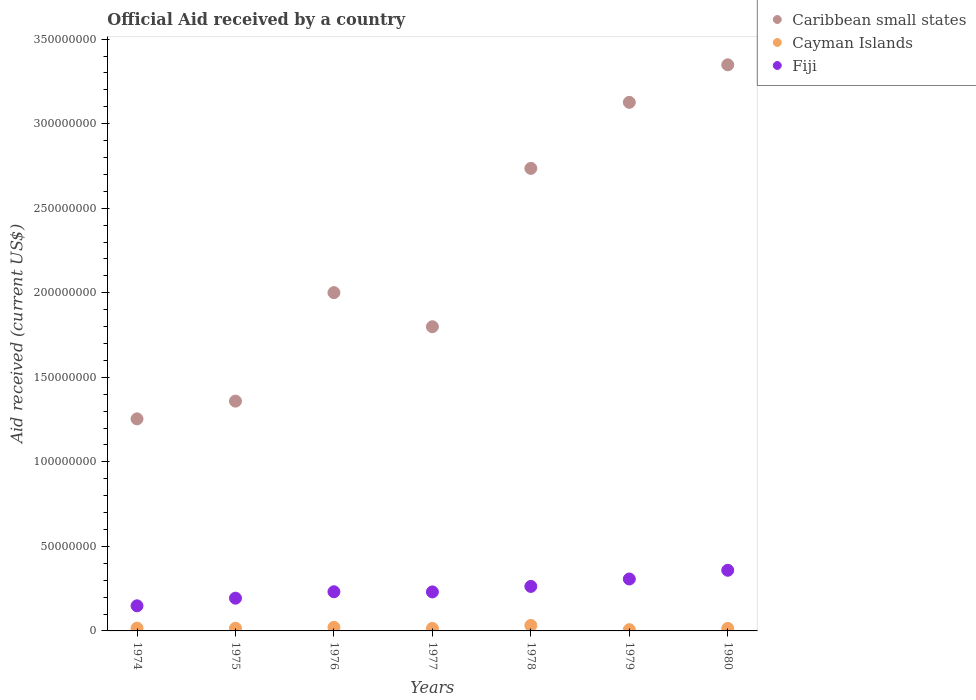How many different coloured dotlines are there?
Provide a succinct answer. 3. Is the number of dotlines equal to the number of legend labels?
Offer a terse response. Yes. What is the net official aid received in Fiji in 1980?
Give a very brief answer. 3.59e+07. Across all years, what is the maximum net official aid received in Caribbean small states?
Your response must be concise. 3.35e+08. Across all years, what is the minimum net official aid received in Caribbean small states?
Provide a succinct answer. 1.25e+08. In which year was the net official aid received in Fiji maximum?
Offer a terse response. 1980. In which year was the net official aid received in Fiji minimum?
Provide a short and direct response. 1974. What is the total net official aid received in Caribbean small states in the graph?
Give a very brief answer. 1.56e+09. What is the difference between the net official aid received in Cayman Islands in 1978 and that in 1979?
Make the answer very short. 2.50e+06. What is the difference between the net official aid received in Fiji in 1979 and the net official aid received in Caribbean small states in 1978?
Make the answer very short. -2.43e+08. What is the average net official aid received in Fiji per year?
Provide a succinct answer. 2.48e+07. In the year 1974, what is the difference between the net official aid received in Cayman Islands and net official aid received in Caribbean small states?
Make the answer very short. -1.24e+08. In how many years, is the net official aid received in Caribbean small states greater than 250000000 US$?
Make the answer very short. 3. What is the ratio of the net official aid received in Caribbean small states in 1974 to that in 1976?
Keep it short and to the point. 0.63. Is the difference between the net official aid received in Cayman Islands in 1977 and 1978 greater than the difference between the net official aid received in Caribbean small states in 1977 and 1978?
Keep it short and to the point. Yes. What is the difference between the highest and the second highest net official aid received in Cayman Islands?
Your answer should be very brief. 1.14e+06. What is the difference between the highest and the lowest net official aid received in Fiji?
Give a very brief answer. 2.10e+07. In how many years, is the net official aid received in Caribbean small states greater than the average net official aid received in Caribbean small states taken over all years?
Provide a short and direct response. 3. Is the net official aid received in Fiji strictly less than the net official aid received in Cayman Islands over the years?
Your answer should be very brief. No. How many dotlines are there?
Make the answer very short. 3. How many years are there in the graph?
Keep it short and to the point. 7. What is the difference between two consecutive major ticks on the Y-axis?
Ensure brevity in your answer.  5.00e+07. Does the graph contain any zero values?
Give a very brief answer. No. Does the graph contain grids?
Offer a very short reply. No. Where does the legend appear in the graph?
Your answer should be very brief. Top right. How are the legend labels stacked?
Your answer should be compact. Vertical. What is the title of the graph?
Give a very brief answer. Official Aid received by a country. Does "Sweden" appear as one of the legend labels in the graph?
Your answer should be very brief. No. What is the label or title of the X-axis?
Your answer should be compact. Years. What is the label or title of the Y-axis?
Offer a terse response. Aid received (current US$). What is the Aid received (current US$) of Caribbean small states in 1974?
Your answer should be very brief. 1.25e+08. What is the Aid received (current US$) of Cayman Islands in 1974?
Ensure brevity in your answer.  1.68e+06. What is the Aid received (current US$) of Fiji in 1974?
Ensure brevity in your answer.  1.48e+07. What is the Aid received (current US$) of Caribbean small states in 1975?
Your response must be concise. 1.36e+08. What is the Aid received (current US$) of Cayman Islands in 1975?
Give a very brief answer. 1.59e+06. What is the Aid received (current US$) of Fiji in 1975?
Provide a succinct answer. 1.94e+07. What is the Aid received (current US$) of Caribbean small states in 1976?
Your answer should be compact. 2.00e+08. What is the Aid received (current US$) in Cayman Islands in 1976?
Keep it short and to the point. 2.10e+06. What is the Aid received (current US$) of Fiji in 1976?
Your answer should be very brief. 2.32e+07. What is the Aid received (current US$) of Caribbean small states in 1977?
Your answer should be very brief. 1.80e+08. What is the Aid received (current US$) in Cayman Islands in 1977?
Keep it short and to the point. 1.49e+06. What is the Aid received (current US$) of Fiji in 1977?
Keep it short and to the point. 2.31e+07. What is the Aid received (current US$) of Caribbean small states in 1978?
Your response must be concise. 2.74e+08. What is the Aid received (current US$) of Cayman Islands in 1978?
Provide a succinct answer. 3.24e+06. What is the Aid received (current US$) in Fiji in 1978?
Provide a short and direct response. 2.63e+07. What is the Aid received (current US$) of Caribbean small states in 1979?
Ensure brevity in your answer.  3.13e+08. What is the Aid received (current US$) of Cayman Islands in 1979?
Your answer should be very brief. 7.40e+05. What is the Aid received (current US$) in Fiji in 1979?
Ensure brevity in your answer.  3.07e+07. What is the Aid received (current US$) of Caribbean small states in 1980?
Provide a succinct answer. 3.35e+08. What is the Aid received (current US$) in Cayman Islands in 1980?
Ensure brevity in your answer.  1.49e+06. What is the Aid received (current US$) of Fiji in 1980?
Give a very brief answer. 3.59e+07. Across all years, what is the maximum Aid received (current US$) in Caribbean small states?
Provide a succinct answer. 3.35e+08. Across all years, what is the maximum Aid received (current US$) in Cayman Islands?
Ensure brevity in your answer.  3.24e+06. Across all years, what is the maximum Aid received (current US$) of Fiji?
Give a very brief answer. 3.59e+07. Across all years, what is the minimum Aid received (current US$) in Caribbean small states?
Provide a succinct answer. 1.25e+08. Across all years, what is the minimum Aid received (current US$) in Cayman Islands?
Give a very brief answer. 7.40e+05. Across all years, what is the minimum Aid received (current US$) of Fiji?
Offer a very short reply. 1.48e+07. What is the total Aid received (current US$) of Caribbean small states in the graph?
Your response must be concise. 1.56e+09. What is the total Aid received (current US$) in Cayman Islands in the graph?
Your answer should be compact. 1.23e+07. What is the total Aid received (current US$) in Fiji in the graph?
Your answer should be very brief. 1.73e+08. What is the difference between the Aid received (current US$) in Caribbean small states in 1974 and that in 1975?
Provide a short and direct response. -1.05e+07. What is the difference between the Aid received (current US$) of Fiji in 1974 and that in 1975?
Make the answer very short. -4.51e+06. What is the difference between the Aid received (current US$) of Caribbean small states in 1974 and that in 1976?
Make the answer very short. -7.47e+07. What is the difference between the Aid received (current US$) in Cayman Islands in 1974 and that in 1976?
Provide a short and direct response. -4.20e+05. What is the difference between the Aid received (current US$) of Fiji in 1974 and that in 1976?
Give a very brief answer. -8.31e+06. What is the difference between the Aid received (current US$) of Caribbean small states in 1974 and that in 1977?
Ensure brevity in your answer.  -5.45e+07. What is the difference between the Aid received (current US$) of Cayman Islands in 1974 and that in 1977?
Your response must be concise. 1.90e+05. What is the difference between the Aid received (current US$) of Fiji in 1974 and that in 1977?
Keep it short and to the point. -8.22e+06. What is the difference between the Aid received (current US$) in Caribbean small states in 1974 and that in 1978?
Offer a very short reply. -1.48e+08. What is the difference between the Aid received (current US$) in Cayman Islands in 1974 and that in 1978?
Your answer should be compact. -1.56e+06. What is the difference between the Aid received (current US$) of Fiji in 1974 and that in 1978?
Your response must be concise. -1.15e+07. What is the difference between the Aid received (current US$) in Caribbean small states in 1974 and that in 1979?
Your response must be concise. -1.87e+08. What is the difference between the Aid received (current US$) in Cayman Islands in 1974 and that in 1979?
Ensure brevity in your answer.  9.40e+05. What is the difference between the Aid received (current US$) of Fiji in 1974 and that in 1979?
Offer a terse response. -1.59e+07. What is the difference between the Aid received (current US$) in Caribbean small states in 1974 and that in 1980?
Keep it short and to the point. -2.09e+08. What is the difference between the Aid received (current US$) in Fiji in 1974 and that in 1980?
Your answer should be very brief. -2.10e+07. What is the difference between the Aid received (current US$) of Caribbean small states in 1975 and that in 1976?
Make the answer very short. -6.42e+07. What is the difference between the Aid received (current US$) in Cayman Islands in 1975 and that in 1976?
Give a very brief answer. -5.10e+05. What is the difference between the Aid received (current US$) of Fiji in 1975 and that in 1976?
Offer a terse response. -3.80e+06. What is the difference between the Aid received (current US$) in Caribbean small states in 1975 and that in 1977?
Make the answer very short. -4.40e+07. What is the difference between the Aid received (current US$) in Cayman Islands in 1975 and that in 1977?
Offer a terse response. 1.00e+05. What is the difference between the Aid received (current US$) in Fiji in 1975 and that in 1977?
Offer a terse response. -3.71e+06. What is the difference between the Aid received (current US$) in Caribbean small states in 1975 and that in 1978?
Your response must be concise. -1.38e+08. What is the difference between the Aid received (current US$) in Cayman Islands in 1975 and that in 1978?
Make the answer very short. -1.65e+06. What is the difference between the Aid received (current US$) of Fiji in 1975 and that in 1978?
Your response must be concise. -6.96e+06. What is the difference between the Aid received (current US$) in Caribbean small states in 1975 and that in 1979?
Your answer should be compact. -1.77e+08. What is the difference between the Aid received (current US$) of Cayman Islands in 1975 and that in 1979?
Make the answer very short. 8.50e+05. What is the difference between the Aid received (current US$) of Fiji in 1975 and that in 1979?
Your answer should be compact. -1.14e+07. What is the difference between the Aid received (current US$) of Caribbean small states in 1975 and that in 1980?
Make the answer very short. -1.99e+08. What is the difference between the Aid received (current US$) in Cayman Islands in 1975 and that in 1980?
Make the answer very short. 1.00e+05. What is the difference between the Aid received (current US$) of Fiji in 1975 and that in 1980?
Ensure brevity in your answer.  -1.65e+07. What is the difference between the Aid received (current US$) of Caribbean small states in 1976 and that in 1977?
Offer a very short reply. 2.02e+07. What is the difference between the Aid received (current US$) of Cayman Islands in 1976 and that in 1977?
Ensure brevity in your answer.  6.10e+05. What is the difference between the Aid received (current US$) in Caribbean small states in 1976 and that in 1978?
Provide a short and direct response. -7.35e+07. What is the difference between the Aid received (current US$) in Cayman Islands in 1976 and that in 1978?
Offer a very short reply. -1.14e+06. What is the difference between the Aid received (current US$) in Fiji in 1976 and that in 1978?
Offer a very short reply. -3.16e+06. What is the difference between the Aid received (current US$) in Caribbean small states in 1976 and that in 1979?
Offer a terse response. -1.13e+08. What is the difference between the Aid received (current US$) in Cayman Islands in 1976 and that in 1979?
Give a very brief answer. 1.36e+06. What is the difference between the Aid received (current US$) of Fiji in 1976 and that in 1979?
Your answer should be very brief. -7.55e+06. What is the difference between the Aid received (current US$) of Caribbean small states in 1976 and that in 1980?
Provide a succinct answer. -1.35e+08. What is the difference between the Aid received (current US$) of Cayman Islands in 1976 and that in 1980?
Provide a succinct answer. 6.10e+05. What is the difference between the Aid received (current US$) of Fiji in 1976 and that in 1980?
Your answer should be compact. -1.27e+07. What is the difference between the Aid received (current US$) of Caribbean small states in 1977 and that in 1978?
Offer a very short reply. -9.36e+07. What is the difference between the Aid received (current US$) in Cayman Islands in 1977 and that in 1978?
Your answer should be compact. -1.75e+06. What is the difference between the Aid received (current US$) in Fiji in 1977 and that in 1978?
Provide a short and direct response. -3.25e+06. What is the difference between the Aid received (current US$) in Caribbean small states in 1977 and that in 1979?
Your answer should be compact. -1.33e+08. What is the difference between the Aid received (current US$) in Cayman Islands in 1977 and that in 1979?
Provide a short and direct response. 7.50e+05. What is the difference between the Aid received (current US$) in Fiji in 1977 and that in 1979?
Your answer should be very brief. -7.64e+06. What is the difference between the Aid received (current US$) of Caribbean small states in 1977 and that in 1980?
Offer a terse response. -1.55e+08. What is the difference between the Aid received (current US$) of Fiji in 1977 and that in 1980?
Offer a very short reply. -1.28e+07. What is the difference between the Aid received (current US$) in Caribbean small states in 1978 and that in 1979?
Offer a very short reply. -3.91e+07. What is the difference between the Aid received (current US$) in Cayman Islands in 1978 and that in 1979?
Ensure brevity in your answer.  2.50e+06. What is the difference between the Aid received (current US$) in Fiji in 1978 and that in 1979?
Provide a succinct answer. -4.39e+06. What is the difference between the Aid received (current US$) in Caribbean small states in 1978 and that in 1980?
Offer a very short reply. -6.13e+07. What is the difference between the Aid received (current US$) of Cayman Islands in 1978 and that in 1980?
Your answer should be very brief. 1.75e+06. What is the difference between the Aid received (current US$) in Fiji in 1978 and that in 1980?
Your answer should be very brief. -9.55e+06. What is the difference between the Aid received (current US$) of Caribbean small states in 1979 and that in 1980?
Give a very brief answer. -2.22e+07. What is the difference between the Aid received (current US$) in Cayman Islands in 1979 and that in 1980?
Ensure brevity in your answer.  -7.50e+05. What is the difference between the Aid received (current US$) of Fiji in 1979 and that in 1980?
Your answer should be compact. -5.16e+06. What is the difference between the Aid received (current US$) in Caribbean small states in 1974 and the Aid received (current US$) in Cayman Islands in 1975?
Provide a succinct answer. 1.24e+08. What is the difference between the Aid received (current US$) of Caribbean small states in 1974 and the Aid received (current US$) of Fiji in 1975?
Provide a succinct answer. 1.06e+08. What is the difference between the Aid received (current US$) of Cayman Islands in 1974 and the Aid received (current US$) of Fiji in 1975?
Your response must be concise. -1.77e+07. What is the difference between the Aid received (current US$) in Caribbean small states in 1974 and the Aid received (current US$) in Cayman Islands in 1976?
Your answer should be very brief. 1.23e+08. What is the difference between the Aid received (current US$) in Caribbean small states in 1974 and the Aid received (current US$) in Fiji in 1976?
Offer a terse response. 1.02e+08. What is the difference between the Aid received (current US$) in Cayman Islands in 1974 and the Aid received (current US$) in Fiji in 1976?
Ensure brevity in your answer.  -2.15e+07. What is the difference between the Aid received (current US$) in Caribbean small states in 1974 and the Aid received (current US$) in Cayman Islands in 1977?
Keep it short and to the point. 1.24e+08. What is the difference between the Aid received (current US$) in Caribbean small states in 1974 and the Aid received (current US$) in Fiji in 1977?
Your response must be concise. 1.02e+08. What is the difference between the Aid received (current US$) in Cayman Islands in 1974 and the Aid received (current US$) in Fiji in 1977?
Your response must be concise. -2.14e+07. What is the difference between the Aid received (current US$) of Caribbean small states in 1974 and the Aid received (current US$) of Cayman Islands in 1978?
Offer a terse response. 1.22e+08. What is the difference between the Aid received (current US$) of Caribbean small states in 1974 and the Aid received (current US$) of Fiji in 1978?
Make the answer very short. 9.91e+07. What is the difference between the Aid received (current US$) in Cayman Islands in 1974 and the Aid received (current US$) in Fiji in 1978?
Give a very brief answer. -2.46e+07. What is the difference between the Aid received (current US$) of Caribbean small states in 1974 and the Aid received (current US$) of Cayman Islands in 1979?
Offer a very short reply. 1.25e+08. What is the difference between the Aid received (current US$) in Caribbean small states in 1974 and the Aid received (current US$) in Fiji in 1979?
Make the answer very short. 9.47e+07. What is the difference between the Aid received (current US$) of Cayman Islands in 1974 and the Aid received (current US$) of Fiji in 1979?
Provide a short and direct response. -2.90e+07. What is the difference between the Aid received (current US$) of Caribbean small states in 1974 and the Aid received (current US$) of Cayman Islands in 1980?
Ensure brevity in your answer.  1.24e+08. What is the difference between the Aid received (current US$) in Caribbean small states in 1974 and the Aid received (current US$) in Fiji in 1980?
Provide a succinct answer. 8.95e+07. What is the difference between the Aid received (current US$) in Cayman Islands in 1974 and the Aid received (current US$) in Fiji in 1980?
Your answer should be very brief. -3.42e+07. What is the difference between the Aid received (current US$) in Caribbean small states in 1975 and the Aid received (current US$) in Cayman Islands in 1976?
Make the answer very short. 1.34e+08. What is the difference between the Aid received (current US$) in Caribbean small states in 1975 and the Aid received (current US$) in Fiji in 1976?
Keep it short and to the point. 1.13e+08. What is the difference between the Aid received (current US$) in Cayman Islands in 1975 and the Aid received (current US$) in Fiji in 1976?
Ensure brevity in your answer.  -2.16e+07. What is the difference between the Aid received (current US$) of Caribbean small states in 1975 and the Aid received (current US$) of Cayman Islands in 1977?
Your response must be concise. 1.34e+08. What is the difference between the Aid received (current US$) of Caribbean small states in 1975 and the Aid received (current US$) of Fiji in 1977?
Make the answer very short. 1.13e+08. What is the difference between the Aid received (current US$) in Cayman Islands in 1975 and the Aid received (current US$) in Fiji in 1977?
Your answer should be very brief. -2.15e+07. What is the difference between the Aid received (current US$) of Caribbean small states in 1975 and the Aid received (current US$) of Cayman Islands in 1978?
Keep it short and to the point. 1.33e+08. What is the difference between the Aid received (current US$) of Caribbean small states in 1975 and the Aid received (current US$) of Fiji in 1978?
Provide a short and direct response. 1.10e+08. What is the difference between the Aid received (current US$) in Cayman Islands in 1975 and the Aid received (current US$) in Fiji in 1978?
Offer a terse response. -2.47e+07. What is the difference between the Aid received (current US$) of Caribbean small states in 1975 and the Aid received (current US$) of Cayman Islands in 1979?
Keep it short and to the point. 1.35e+08. What is the difference between the Aid received (current US$) of Caribbean small states in 1975 and the Aid received (current US$) of Fiji in 1979?
Give a very brief answer. 1.05e+08. What is the difference between the Aid received (current US$) of Cayman Islands in 1975 and the Aid received (current US$) of Fiji in 1979?
Ensure brevity in your answer.  -2.91e+07. What is the difference between the Aid received (current US$) of Caribbean small states in 1975 and the Aid received (current US$) of Cayman Islands in 1980?
Provide a succinct answer. 1.34e+08. What is the difference between the Aid received (current US$) in Caribbean small states in 1975 and the Aid received (current US$) in Fiji in 1980?
Give a very brief answer. 1.00e+08. What is the difference between the Aid received (current US$) in Cayman Islands in 1975 and the Aid received (current US$) in Fiji in 1980?
Offer a very short reply. -3.43e+07. What is the difference between the Aid received (current US$) in Caribbean small states in 1976 and the Aid received (current US$) in Cayman Islands in 1977?
Ensure brevity in your answer.  1.99e+08. What is the difference between the Aid received (current US$) of Caribbean small states in 1976 and the Aid received (current US$) of Fiji in 1977?
Your answer should be compact. 1.77e+08. What is the difference between the Aid received (current US$) of Cayman Islands in 1976 and the Aid received (current US$) of Fiji in 1977?
Keep it short and to the point. -2.10e+07. What is the difference between the Aid received (current US$) in Caribbean small states in 1976 and the Aid received (current US$) in Cayman Islands in 1978?
Ensure brevity in your answer.  1.97e+08. What is the difference between the Aid received (current US$) in Caribbean small states in 1976 and the Aid received (current US$) in Fiji in 1978?
Your response must be concise. 1.74e+08. What is the difference between the Aid received (current US$) of Cayman Islands in 1976 and the Aid received (current US$) of Fiji in 1978?
Keep it short and to the point. -2.42e+07. What is the difference between the Aid received (current US$) of Caribbean small states in 1976 and the Aid received (current US$) of Cayman Islands in 1979?
Provide a short and direct response. 1.99e+08. What is the difference between the Aid received (current US$) of Caribbean small states in 1976 and the Aid received (current US$) of Fiji in 1979?
Your answer should be very brief. 1.69e+08. What is the difference between the Aid received (current US$) in Cayman Islands in 1976 and the Aid received (current US$) in Fiji in 1979?
Provide a short and direct response. -2.86e+07. What is the difference between the Aid received (current US$) in Caribbean small states in 1976 and the Aid received (current US$) in Cayman Islands in 1980?
Provide a short and direct response. 1.99e+08. What is the difference between the Aid received (current US$) in Caribbean small states in 1976 and the Aid received (current US$) in Fiji in 1980?
Provide a short and direct response. 1.64e+08. What is the difference between the Aid received (current US$) in Cayman Islands in 1976 and the Aid received (current US$) in Fiji in 1980?
Offer a terse response. -3.38e+07. What is the difference between the Aid received (current US$) of Caribbean small states in 1977 and the Aid received (current US$) of Cayman Islands in 1978?
Your answer should be very brief. 1.77e+08. What is the difference between the Aid received (current US$) in Caribbean small states in 1977 and the Aid received (current US$) in Fiji in 1978?
Provide a short and direct response. 1.54e+08. What is the difference between the Aid received (current US$) in Cayman Islands in 1977 and the Aid received (current US$) in Fiji in 1978?
Ensure brevity in your answer.  -2.48e+07. What is the difference between the Aid received (current US$) in Caribbean small states in 1977 and the Aid received (current US$) in Cayman Islands in 1979?
Your answer should be compact. 1.79e+08. What is the difference between the Aid received (current US$) of Caribbean small states in 1977 and the Aid received (current US$) of Fiji in 1979?
Give a very brief answer. 1.49e+08. What is the difference between the Aid received (current US$) in Cayman Islands in 1977 and the Aid received (current US$) in Fiji in 1979?
Make the answer very short. -2.92e+07. What is the difference between the Aid received (current US$) of Caribbean small states in 1977 and the Aid received (current US$) of Cayman Islands in 1980?
Your response must be concise. 1.78e+08. What is the difference between the Aid received (current US$) in Caribbean small states in 1977 and the Aid received (current US$) in Fiji in 1980?
Give a very brief answer. 1.44e+08. What is the difference between the Aid received (current US$) in Cayman Islands in 1977 and the Aid received (current US$) in Fiji in 1980?
Ensure brevity in your answer.  -3.44e+07. What is the difference between the Aid received (current US$) in Caribbean small states in 1978 and the Aid received (current US$) in Cayman Islands in 1979?
Offer a terse response. 2.73e+08. What is the difference between the Aid received (current US$) in Caribbean small states in 1978 and the Aid received (current US$) in Fiji in 1979?
Keep it short and to the point. 2.43e+08. What is the difference between the Aid received (current US$) in Cayman Islands in 1978 and the Aid received (current US$) in Fiji in 1979?
Make the answer very short. -2.75e+07. What is the difference between the Aid received (current US$) of Caribbean small states in 1978 and the Aid received (current US$) of Cayman Islands in 1980?
Offer a terse response. 2.72e+08. What is the difference between the Aid received (current US$) of Caribbean small states in 1978 and the Aid received (current US$) of Fiji in 1980?
Make the answer very short. 2.38e+08. What is the difference between the Aid received (current US$) of Cayman Islands in 1978 and the Aid received (current US$) of Fiji in 1980?
Make the answer very short. -3.26e+07. What is the difference between the Aid received (current US$) of Caribbean small states in 1979 and the Aid received (current US$) of Cayman Islands in 1980?
Your answer should be compact. 3.11e+08. What is the difference between the Aid received (current US$) of Caribbean small states in 1979 and the Aid received (current US$) of Fiji in 1980?
Make the answer very short. 2.77e+08. What is the difference between the Aid received (current US$) of Cayman Islands in 1979 and the Aid received (current US$) of Fiji in 1980?
Ensure brevity in your answer.  -3.51e+07. What is the average Aid received (current US$) in Caribbean small states per year?
Your response must be concise. 2.23e+08. What is the average Aid received (current US$) in Cayman Islands per year?
Your answer should be compact. 1.76e+06. What is the average Aid received (current US$) in Fiji per year?
Offer a very short reply. 2.48e+07. In the year 1974, what is the difference between the Aid received (current US$) in Caribbean small states and Aid received (current US$) in Cayman Islands?
Keep it short and to the point. 1.24e+08. In the year 1974, what is the difference between the Aid received (current US$) of Caribbean small states and Aid received (current US$) of Fiji?
Make the answer very short. 1.11e+08. In the year 1974, what is the difference between the Aid received (current US$) in Cayman Islands and Aid received (current US$) in Fiji?
Offer a terse response. -1.32e+07. In the year 1975, what is the difference between the Aid received (current US$) in Caribbean small states and Aid received (current US$) in Cayman Islands?
Offer a terse response. 1.34e+08. In the year 1975, what is the difference between the Aid received (current US$) in Caribbean small states and Aid received (current US$) in Fiji?
Ensure brevity in your answer.  1.17e+08. In the year 1975, what is the difference between the Aid received (current US$) of Cayman Islands and Aid received (current US$) of Fiji?
Make the answer very short. -1.78e+07. In the year 1976, what is the difference between the Aid received (current US$) of Caribbean small states and Aid received (current US$) of Cayman Islands?
Keep it short and to the point. 1.98e+08. In the year 1976, what is the difference between the Aid received (current US$) in Caribbean small states and Aid received (current US$) in Fiji?
Your response must be concise. 1.77e+08. In the year 1976, what is the difference between the Aid received (current US$) in Cayman Islands and Aid received (current US$) in Fiji?
Your answer should be compact. -2.11e+07. In the year 1977, what is the difference between the Aid received (current US$) of Caribbean small states and Aid received (current US$) of Cayman Islands?
Your response must be concise. 1.78e+08. In the year 1977, what is the difference between the Aid received (current US$) in Caribbean small states and Aid received (current US$) in Fiji?
Your answer should be very brief. 1.57e+08. In the year 1977, what is the difference between the Aid received (current US$) of Cayman Islands and Aid received (current US$) of Fiji?
Your response must be concise. -2.16e+07. In the year 1978, what is the difference between the Aid received (current US$) in Caribbean small states and Aid received (current US$) in Cayman Islands?
Make the answer very short. 2.70e+08. In the year 1978, what is the difference between the Aid received (current US$) of Caribbean small states and Aid received (current US$) of Fiji?
Offer a very short reply. 2.47e+08. In the year 1978, what is the difference between the Aid received (current US$) in Cayman Islands and Aid received (current US$) in Fiji?
Provide a short and direct response. -2.31e+07. In the year 1979, what is the difference between the Aid received (current US$) of Caribbean small states and Aid received (current US$) of Cayman Islands?
Your response must be concise. 3.12e+08. In the year 1979, what is the difference between the Aid received (current US$) of Caribbean small states and Aid received (current US$) of Fiji?
Make the answer very short. 2.82e+08. In the year 1979, what is the difference between the Aid received (current US$) in Cayman Islands and Aid received (current US$) in Fiji?
Your response must be concise. -3.00e+07. In the year 1980, what is the difference between the Aid received (current US$) in Caribbean small states and Aid received (current US$) in Cayman Islands?
Your response must be concise. 3.33e+08. In the year 1980, what is the difference between the Aid received (current US$) of Caribbean small states and Aid received (current US$) of Fiji?
Keep it short and to the point. 2.99e+08. In the year 1980, what is the difference between the Aid received (current US$) in Cayman Islands and Aid received (current US$) in Fiji?
Provide a short and direct response. -3.44e+07. What is the ratio of the Aid received (current US$) of Caribbean small states in 1974 to that in 1975?
Offer a terse response. 0.92. What is the ratio of the Aid received (current US$) in Cayman Islands in 1974 to that in 1975?
Your response must be concise. 1.06. What is the ratio of the Aid received (current US$) of Fiji in 1974 to that in 1975?
Offer a very short reply. 0.77. What is the ratio of the Aid received (current US$) of Caribbean small states in 1974 to that in 1976?
Offer a terse response. 0.63. What is the ratio of the Aid received (current US$) in Cayman Islands in 1974 to that in 1976?
Offer a very short reply. 0.8. What is the ratio of the Aid received (current US$) in Fiji in 1974 to that in 1976?
Make the answer very short. 0.64. What is the ratio of the Aid received (current US$) in Caribbean small states in 1974 to that in 1977?
Keep it short and to the point. 0.7. What is the ratio of the Aid received (current US$) in Cayman Islands in 1974 to that in 1977?
Your answer should be compact. 1.13. What is the ratio of the Aid received (current US$) of Fiji in 1974 to that in 1977?
Provide a short and direct response. 0.64. What is the ratio of the Aid received (current US$) of Caribbean small states in 1974 to that in 1978?
Make the answer very short. 0.46. What is the ratio of the Aid received (current US$) of Cayman Islands in 1974 to that in 1978?
Offer a very short reply. 0.52. What is the ratio of the Aid received (current US$) of Fiji in 1974 to that in 1978?
Your answer should be compact. 0.56. What is the ratio of the Aid received (current US$) of Caribbean small states in 1974 to that in 1979?
Make the answer very short. 0.4. What is the ratio of the Aid received (current US$) in Cayman Islands in 1974 to that in 1979?
Ensure brevity in your answer.  2.27. What is the ratio of the Aid received (current US$) of Fiji in 1974 to that in 1979?
Your answer should be compact. 0.48. What is the ratio of the Aid received (current US$) in Caribbean small states in 1974 to that in 1980?
Your answer should be very brief. 0.37. What is the ratio of the Aid received (current US$) in Cayman Islands in 1974 to that in 1980?
Ensure brevity in your answer.  1.13. What is the ratio of the Aid received (current US$) in Fiji in 1974 to that in 1980?
Provide a succinct answer. 0.41. What is the ratio of the Aid received (current US$) of Caribbean small states in 1975 to that in 1976?
Keep it short and to the point. 0.68. What is the ratio of the Aid received (current US$) in Cayman Islands in 1975 to that in 1976?
Keep it short and to the point. 0.76. What is the ratio of the Aid received (current US$) in Fiji in 1975 to that in 1976?
Your response must be concise. 0.84. What is the ratio of the Aid received (current US$) of Caribbean small states in 1975 to that in 1977?
Make the answer very short. 0.76. What is the ratio of the Aid received (current US$) in Cayman Islands in 1975 to that in 1977?
Provide a succinct answer. 1.07. What is the ratio of the Aid received (current US$) in Fiji in 1975 to that in 1977?
Provide a succinct answer. 0.84. What is the ratio of the Aid received (current US$) in Caribbean small states in 1975 to that in 1978?
Your answer should be compact. 0.5. What is the ratio of the Aid received (current US$) in Cayman Islands in 1975 to that in 1978?
Your answer should be very brief. 0.49. What is the ratio of the Aid received (current US$) of Fiji in 1975 to that in 1978?
Your answer should be very brief. 0.74. What is the ratio of the Aid received (current US$) of Caribbean small states in 1975 to that in 1979?
Provide a short and direct response. 0.43. What is the ratio of the Aid received (current US$) in Cayman Islands in 1975 to that in 1979?
Ensure brevity in your answer.  2.15. What is the ratio of the Aid received (current US$) of Fiji in 1975 to that in 1979?
Provide a short and direct response. 0.63. What is the ratio of the Aid received (current US$) in Caribbean small states in 1975 to that in 1980?
Make the answer very short. 0.41. What is the ratio of the Aid received (current US$) of Cayman Islands in 1975 to that in 1980?
Your answer should be compact. 1.07. What is the ratio of the Aid received (current US$) of Fiji in 1975 to that in 1980?
Give a very brief answer. 0.54. What is the ratio of the Aid received (current US$) of Caribbean small states in 1976 to that in 1977?
Provide a short and direct response. 1.11. What is the ratio of the Aid received (current US$) of Cayman Islands in 1976 to that in 1977?
Your answer should be compact. 1.41. What is the ratio of the Aid received (current US$) in Fiji in 1976 to that in 1977?
Provide a succinct answer. 1. What is the ratio of the Aid received (current US$) of Caribbean small states in 1976 to that in 1978?
Ensure brevity in your answer.  0.73. What is the ratio of the Aid received (current US$) of Cayman Islands in 1976 to that in 1978?
Make the answer very short. 0.65. What is the ratio of the Aid received (current US$) of Fiji in 1976 to that in 1978?
Keep it short and to the point. 0.88. What is the ratio of the Aid received (current US$) of Caribbean small states in 1976 to that in 1979?
Provide a short and direct response. 0.64. What is the ratio of the Aid received (current US$) of Cayman Islands in 1976 to that in 1979?
Provide a short and direct response. 2.84. What is the ratio of the Aid received (current US$) of Fiji in 1976 to that in 1979?
Make the answer very short. 0.75. What is the ratio of the Aid received (current US$) in Caribbean small states in 1976 to that in 1980?
Your answer should be compact. 0.6. What is the ratio of the Aid received (current US$) in Cayman Islands in 1976 to that in 1980?
Ensure brevity in your answer.  1.41. What is the ratio of the Aid received (current US$) in Fiji in 1976 to that in 1980?
Provide a short and direct response. 0.65. What is the ratio of the Aid received (current US$) of Caribbean small states in 1977 to that in 1978?
Your answer should be very brief. 0.66. What is the ratio of the Aid received (current US$) of Cayman Islands in 1977 to that in 1978?
Provide a succinct answer. 0.46. What is the ratio of the Aid received (current US$) of Fiji in 1977 to that in 1978?
Make the answer very short. 0.88. What is the ratio of the Aid received (current US$) in Caribbean small states in 1977 to that in 1979?
Your response must be concise. 0.58. What is the ratio of the Aid received (current US$) of Cayman Islands in 1977 to that in 1979?
Keep it short and to the point. 2.01. What is the ratio of the Aid received (current US$) in Fiji in 1977 to that in 1979?
Make the answer very short. 0.75. What is the ratio of the Aid received (current US$) of Caribbean small states in 1977 to that in 1980?
Your answer should be very brief. 0.54. What is the ratio of the Aid received (current US$) of Cayman Islands in 1977 to that in 1980?
Ensure brevity in your answer.  1. What is the ratio of the Aid received (current US$) in Fiji in 1977 to that in 1980?
Provide a short and direct response. 0.64. What is the ratio of the Aid received (current US$) of Cayman Islands in 1978 to that in 1979?
Your answer should be compact. 4.38. What is the ratio of the Aid received (current US$) of Fiji in 1978 to that in 1979?
Make the answer very short. 0.86. What is the ratio of the Aid received (current US$) in Caribbean small states in 1978 to that in 1980?
Ensure brevity in your answer.  0.82. What is the ratio of the Aid received (current US$) in Cayman Islands in 1978 to that in 1980?
Give a very brief answer. 2.17. What is the ratio of the Aid received (current US$) of Fiji in 1978 to that in 1980?
Make the answer very short. 0.73. What is the ratio of the Aid received (current US$) of Caribbean small states in 1979 to that in 1980?
Give a very brief answer. 0.93. What is the ratio of the Aid received (current US$) in Cayman Islands in 1979 to that in 1980?
Your answer should be very brief. 0.5. What is the ratio of the Aid received (current US$) of Fiji in 1979 to that in 1980?
Offer a terse response. 0.86. What is the difference between the highest and the second highest Aid received (current US$) in Caribbean small states?
Ensure brevity in your answer.  2.22e+07. What is the difference between the highest and the second highest Aid received (current US$) of Cayman Islands?
Provide a succinct answer. 1.14e+06. What is the difference between the highest and the second highest Aid received (current US$) of Fiji?
Provide a succinct answer. 5.16e+06. What is the difference between the highest and the lowest Aid received (current US$) of Caribbean small states?
Give a very brief answer. 2.09e+08. What is the difference between the highest and the lowest Aid received (current US$) of Cayman Islands?
Provide a short and direct response. 2.50e+06. What is the difference between the highest and the lowest Aid received (current US$) in Fiji?
Your response must be concise. 2.10e+07. 